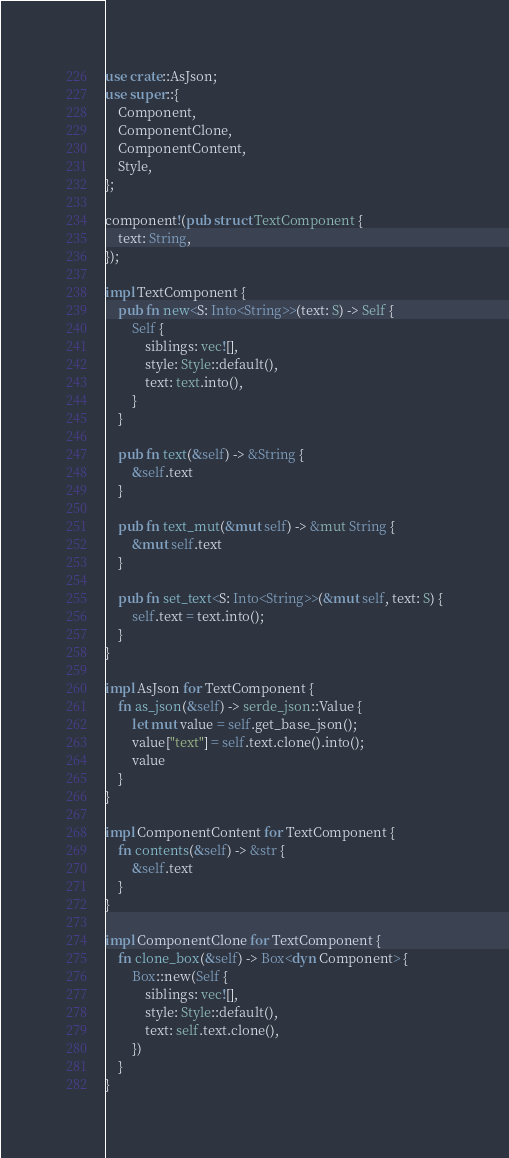Convert code to text. <code><loc_0><loc_0><loc_500><loc_500><_Rust_>use crate::AsJson;
use super::{
    Component,
    ComponentClone,
    ComponentContent,
    Style,
};

component!(pub struct TextComponent {
    text: String,
});

impl TextComponent {
    pub fn new<S: Into<String>>(text: S) -> Self {
        Self {
            siblings: vec![],
            style: Style::default(),
            text: text.into(),
        }
    }

    pub fn text(&self) -> &String {
        &self.text
    }

    pub fn text_mut(&mut self) -> &mut String {
        &mut self.text
    }

    pub fn set_text<S: Into<String>>(&mut self, text: S) {
        self.text = text.into();
    }
}

impl AsJson for TextComponent {
    fn as_json(&self) -> serde_json::Value {
        let mut value = self.get_base_json();
        value["text"] = self.text.clone().into();
        value
    }
}

impl ComponentContent for TextComponent {
    fn contents(&self) -> &str {
        &self.text
    }
}

impl ComponentClone for TextComponent {
    fn clone_box(&self) -> Box<dyn Component> {
        Box::new(Self {
            siblings: vec![],
            style: Style::default(),
            text: self.text.clone(),
        })
    }
}
</code> 